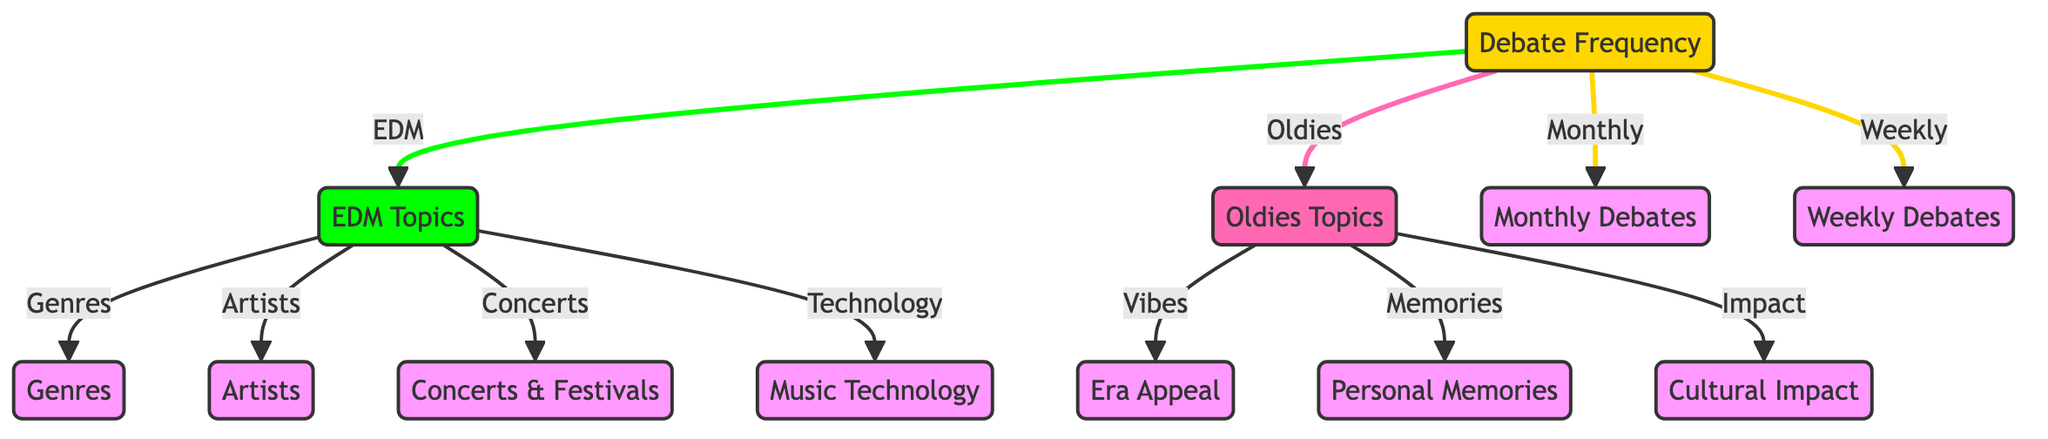What are the two types of debate frequencies shown? The diagram indicates two types of debate frequencies: "Monthly" and "Weekly", connected to the main node "Debate Frequency".
Answer: Monthly, Weekly How many topics are related to EDM? There are four topics related to EDM, which include "Genres", "Artists", "Concerts", and "Technology".
Answer: 4 What is one of the topics under Oldies? The diagram shows three topics under Oldies, one of which is "Personal Memories".
Answer: Personal Memories What is the relationship between debate frequency and Oldies? The connection shows that "Debate Frequency" has a branch leading directly to "Oldies Topics", indicating both are part of the same higher-level concept that includes debate topics.
Answer: Leads to Oldies Topics Which topic describes a feeling associated with Oldies? "Vibes" is the topic connected to Oldies, referring to the emotional resonance older music styles may evoke.
Answer: Vibes What types of topics are associated with EDM and Oldies respectively? EDM topics include more modern elements like "Technology", while Oldies topics focus on nostalgia-related aspects like "Cultural Impact".
Answer: Technology, Cultural Impact How many total topics are covered by both EDM and Oldies? Combining the topics for EDM (4) and Oldies (3), the total number of topics covered is seven.
Answer: 7 What kind of music events are linked to EDM? The diagram specifies that "Concerts & Festivals" are linked to EDM, indicating its relevance in that genre's community and experience.
Answer: Concerts & Festivals How many edges connect "Debate Frequency" to its subtopics? "Debate Frequency" connects to four subtopics: "EDM", "Oldies", "Monthly", and "Weekly", making a total of four edges.
Answer: 4 